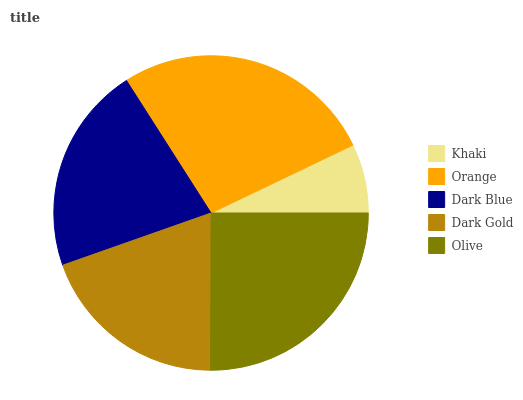Is Khaki the minimum?
Answer yes or no. Yes. Is Orange the maximum?
Answer yes or no. Yes. Is Dark Blue the minimum?
Answer yes or no. No. Is Dark Blue the maximum?
Answer yes or no. No. Is Orange greater than Dark Blue?
Answer yes or no. Yes. Is Dark Blue less than Orange?
Answer yes or no. Yes. Is Dark Blue greater than Orange?
Answer yes or no. No. Is Orange less than Dark Blue?
Answer yes or no. No. Is Dark Blue the high median?
Answer yes or no. Yes. Is Dark Blue the low median?
Answer yes or no. Yes. Is Olive the high median?
Answer yes or no. No. Is Khaki the low median?
Answer yes or no. No. 